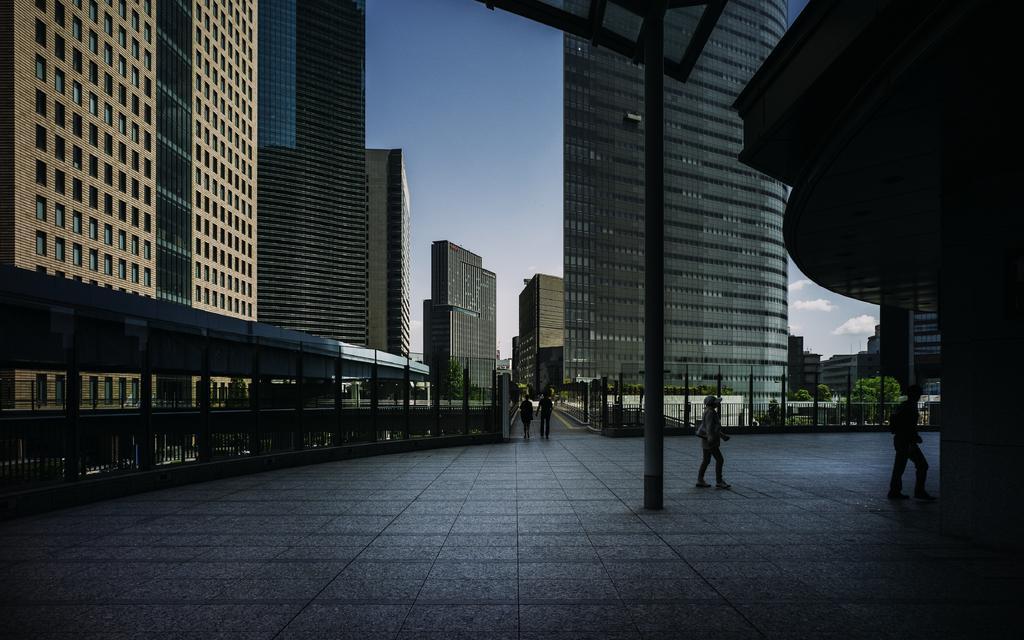Please provide a concise description of this image. In this image there are people walking. There are buildings, trees, poles and a metal fence. At the top of the image there are clouds in the sky. 